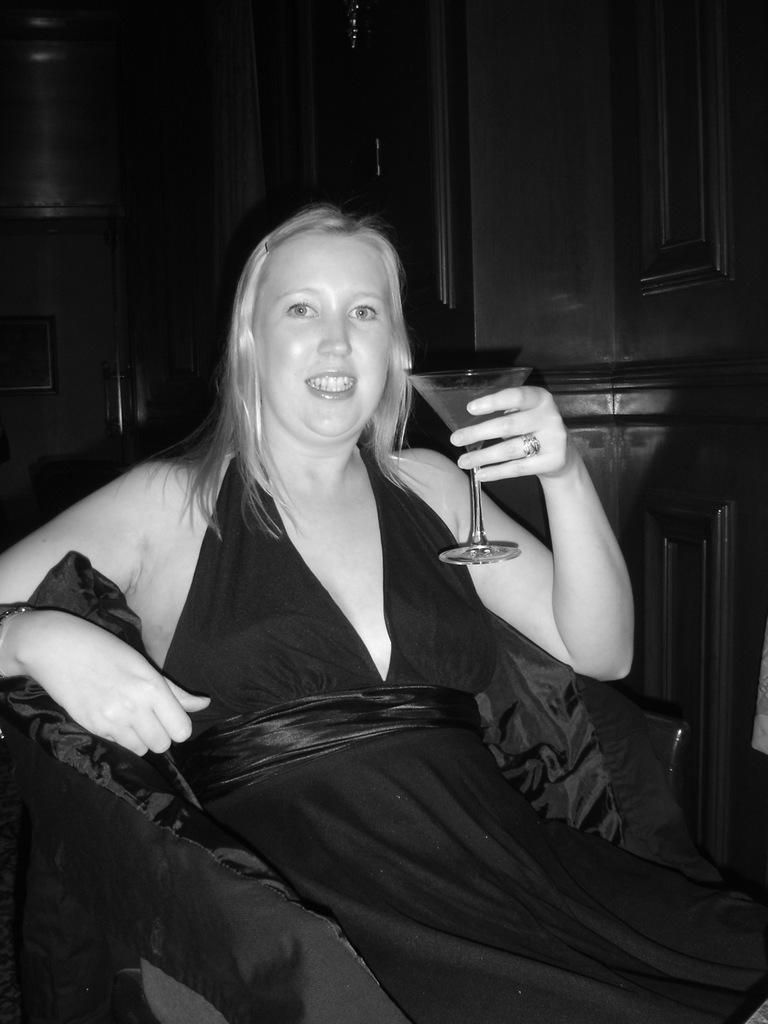What is the color scheme of the image? The image is black and white. What is the woman in the image doing? The woman is sitting on a chair. What is the woman holding in the image? The woman is holding a glass. What can be seen at the back side of the image? There are cupboards at the back side of the image. Can you see the woman's approval of the toe in the image? There is no mention of a toe or approval in the image, so it cannot be determined from the image. 